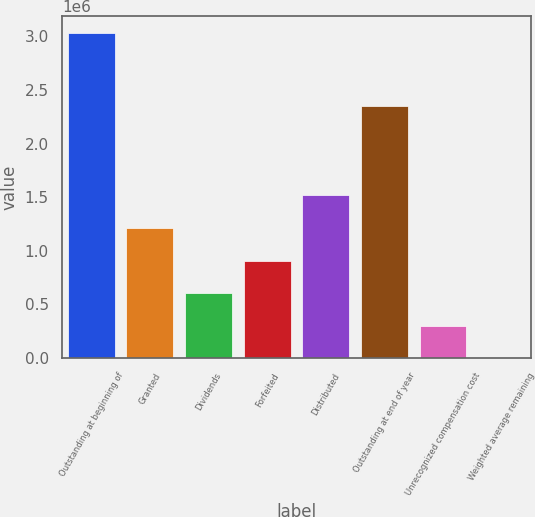Convert chart. <chart><loc_0><loc_0><loc_500><loc_500><bar_chart><fcel>Outstanding at beginning of<fcel>Granted<fcel>Dividends<fcel>Forfeited<fcel>Distributed<fcel>Outstanding at end of year<fcel>Unrecognized compensation cost<fcel>Weighted average remaining<nl><fcel>3.03254e+06<fcel>1.21302e+06<fcel>606509<fcel>909763<fcel>1.51627e+06<fcel>2.34664e+06<fcel>303256<fcel>1.8<nl></chart> 